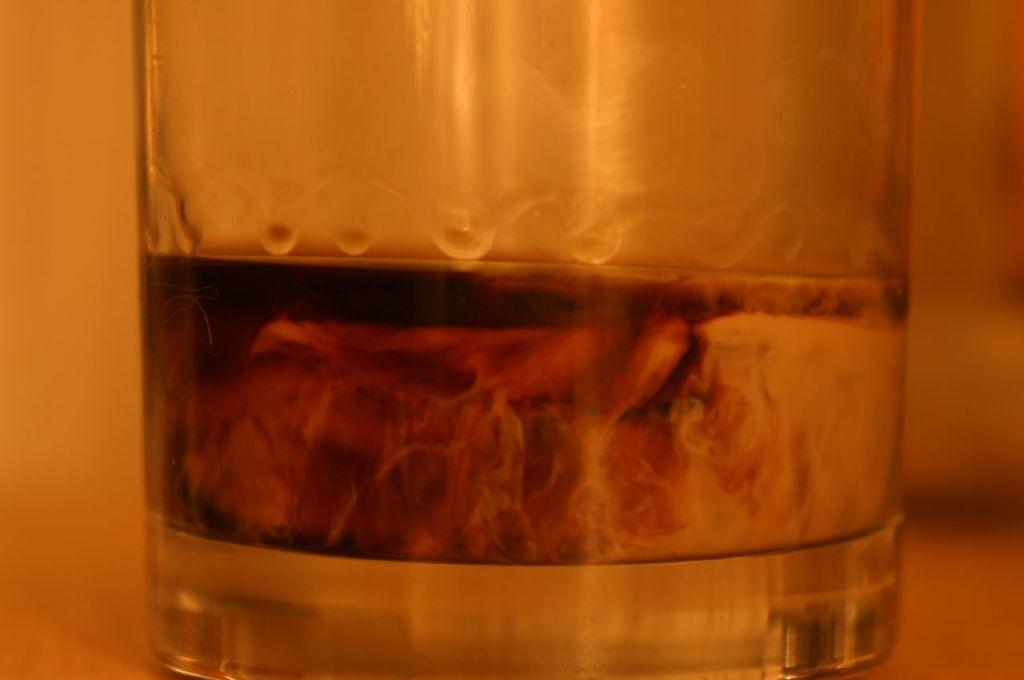Can you describe this image briefly? In this picture, we see a glass containing a liquid. This glass might be placed on the table. In the background, it is white in color and this picture is blurred in the background. 